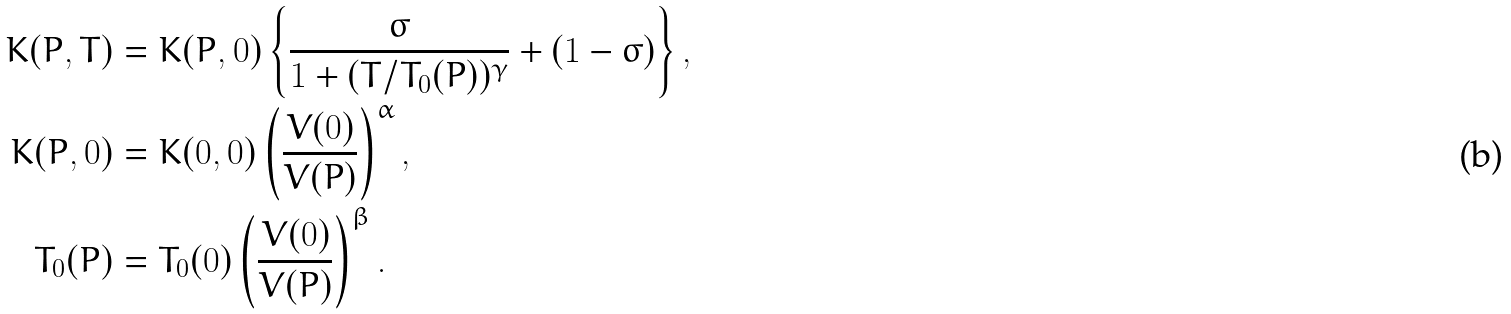Convert formula to latex. <formula><loc_0><loc_0><loc_500><loc_500>K ( P , T ) & = K ( P , 0 ) \left \{ \frac { \sigma } { 1 + ( T / T _ { 0 } ( P ) ) ^ { \gamma } } + ( 1 - \sigma ) \right \} , \\ K ( P , 0 ) & = K ( 0 , 0 ) \left ( \frac { V ( 0 ) } { V ( P ) } \right ) ^ { \alpha } , \\ T _ { 0 } ( P ) & = T _ { 0 } ( 0 ) \left ( \frac { V ( 0 ) } { V ( P ) } \right ) ^ { \beta } .</formula> 